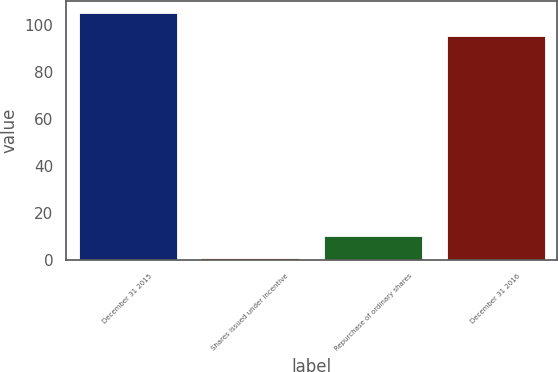<chart> <loc_0><loc_0><loc_500><loc_500><bar_chart><fcel>December 31 2015<fcel>Shares issued under incentive<fcel>Repurchase of ordinary shares<fcel>December 31 2016<nl><fcel>104.84<fcel>0.6<fcel>10.14<fcel>95.3<nl></chart> 